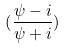Convert formula to latex. <formula><loc_0><loc_0><loc_500><loc_500>( \frac { \psi - i } { \psi + i } )</formula> 